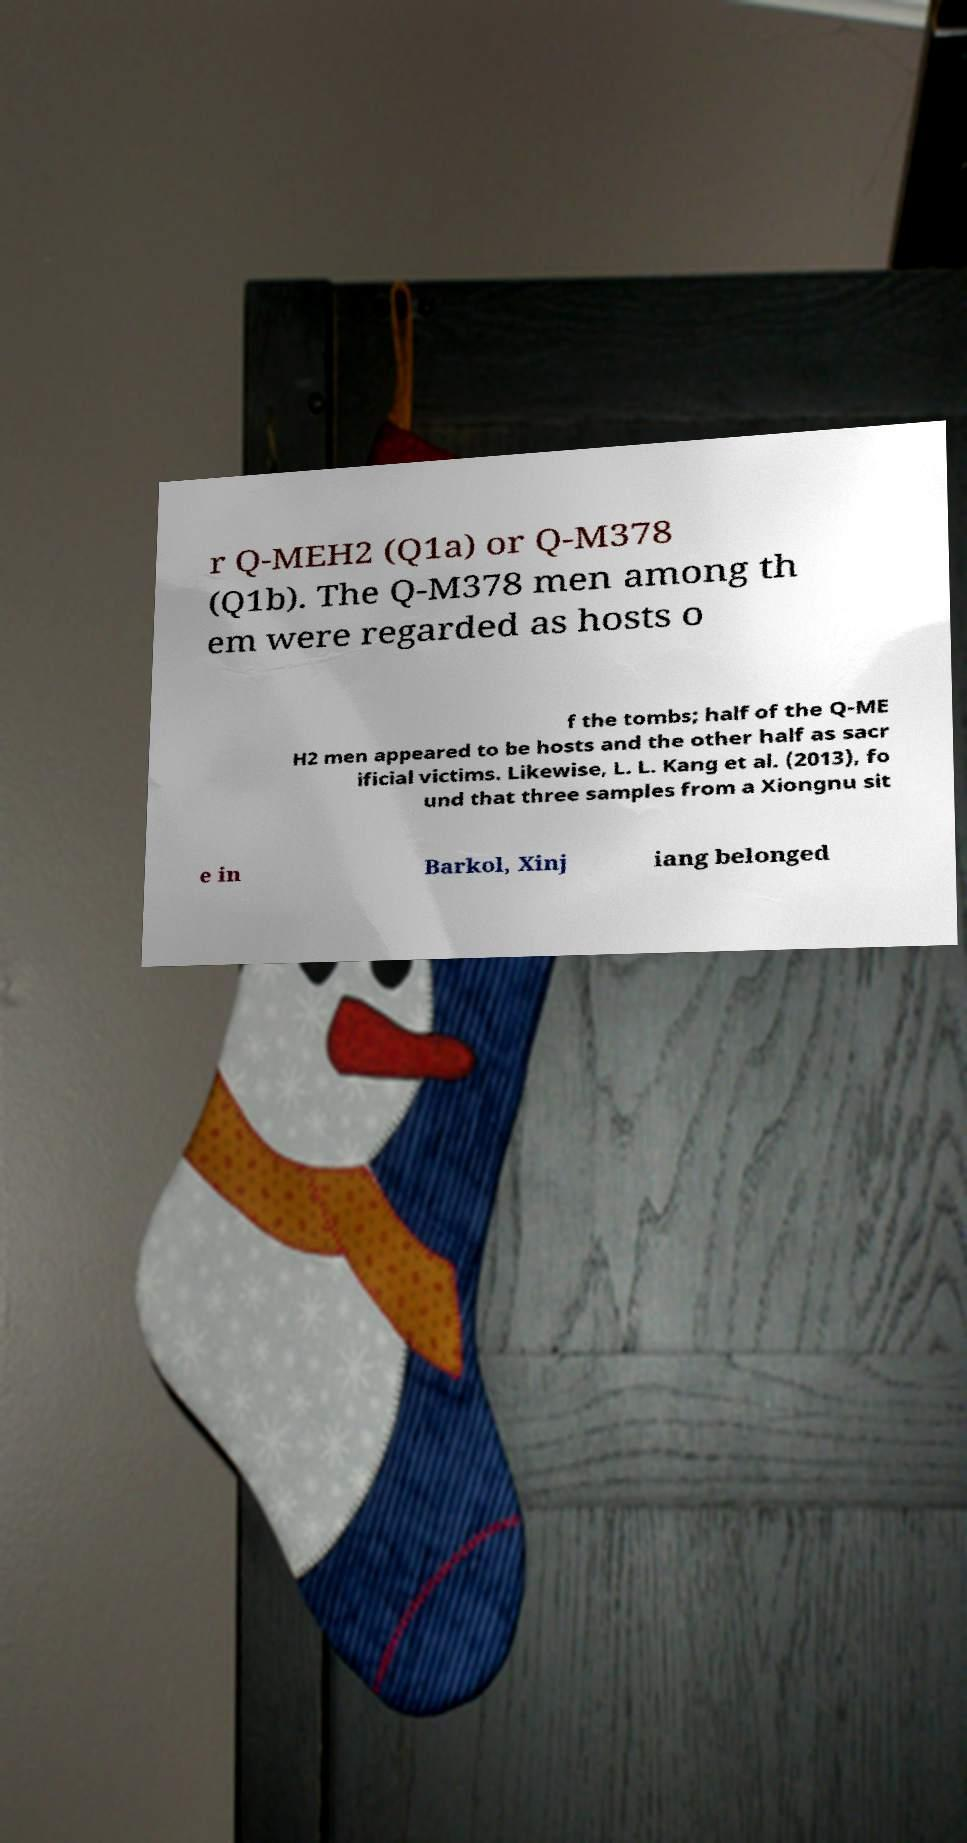Please identify and transcribe the text found in this image. r Q-MEH2 (Q1a) or Q-M378 (Q1b). The Q-M378 men among th em were regarded as hosts o f the tombs; half of the Q-ME H2 men appeared to be hosts and the other half as sacr ificial victims. Likewise, L. L. Kang et al. (2013), fo und that three samples from a Xiongnu sit e in Barkol, Xinj iang belonged 